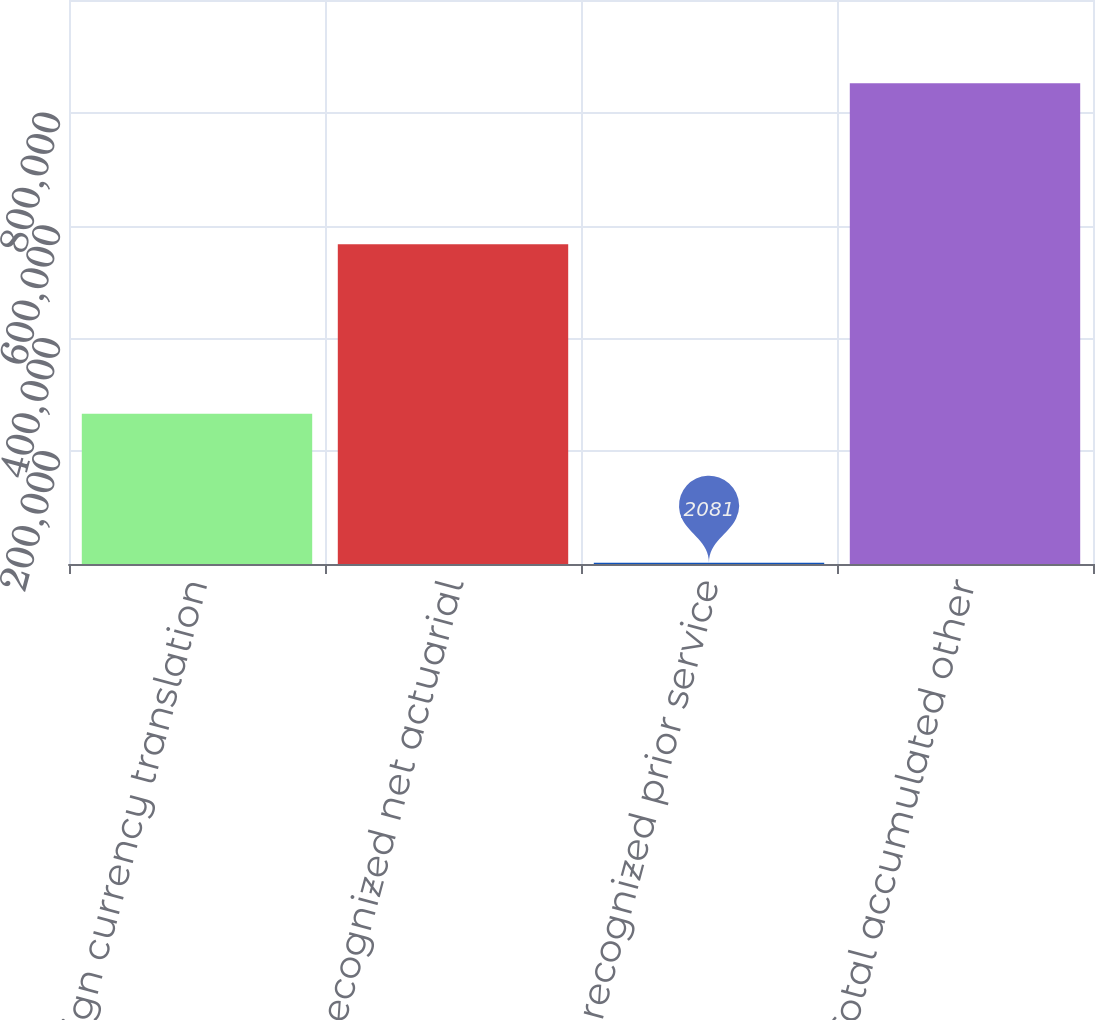<chart> <loc_0><loc_0><loc_500><loc_500><bar_chart><fcel>Foreign currency translation<fcel>Unrecognized net actuarial<fcel>Unrecognized prior service<fcel>Total accumulated other<nl><fcel>266247<fcel>566876<fcel>2081<fcel>852592<nl></chart> 